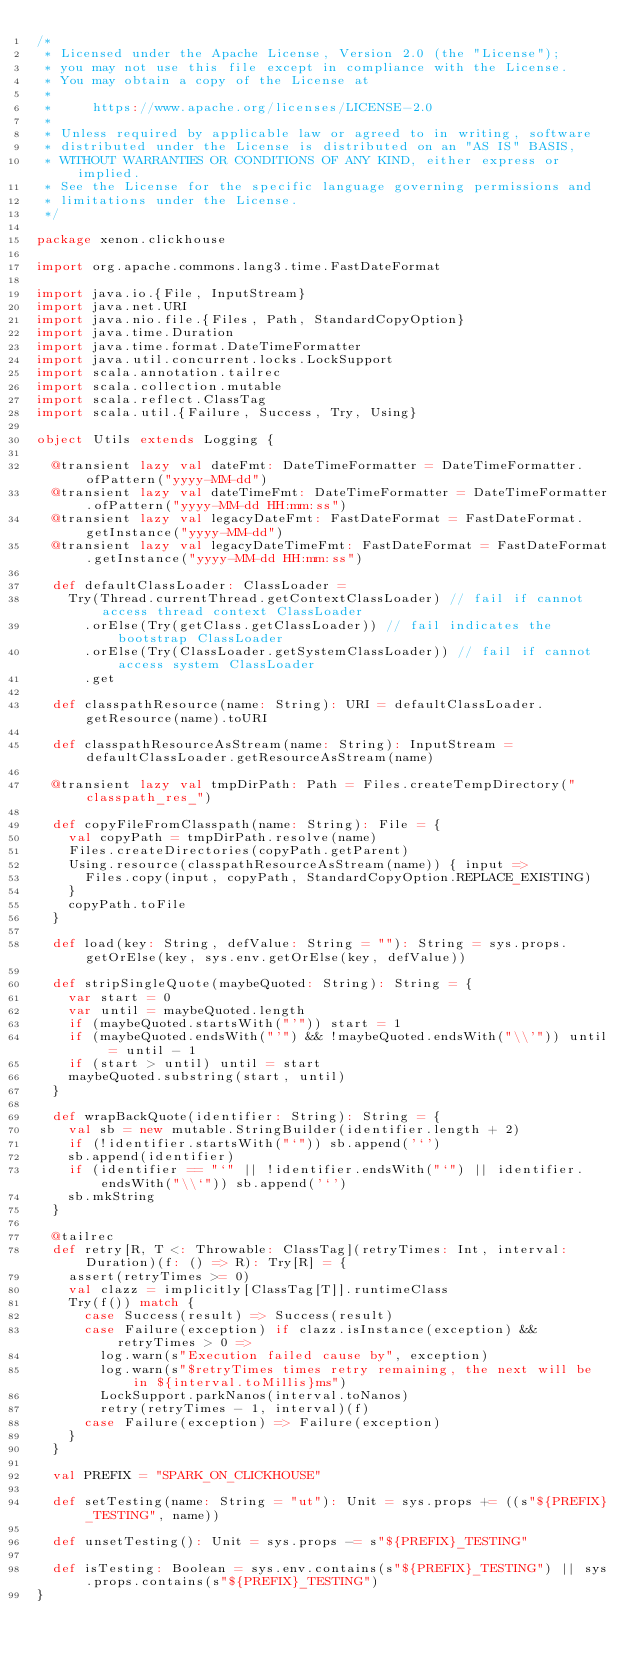<code> <loc_0><loc_0><loc_500><loc_500><_Scala_>/*
 * Licensed under the Apache License, Version 2.0 (the "License");
 * you may not use this file except in compliance with the License.
 * You may obtain a copy of the License at
 *
 *     https://www.apache.org/licenses/LICENSE-2.0
 *
 * Unless required by applicable law or agreed to in writing, software
 * distributed under the License is distributed on an "AS IS" BASIS,
 * WITHOUT WARRANTIES OR CONDITIONS OF ANY KIND, either express or implied.
 * See the License for the specific language governing permissions and
 * limitations under the License.
 */

package xenon.clickhouse

import org.apache.commons.lang3.time.FastDateFormat

import java.io.{File, InputStream}
import java.net.URI
import java.nio.file.{Files, Path, StandardCopyOption}
import java.time.Duration
import java.time.format.DateTimeFormatter
import java.util.concurrent.locks.LockSupport
import scala.annotation.tailrec
import scala.collection.mutable
import scala.reflect.ClassTag
import scala.util.{Failure, Success, Try, Using}

object Utils extends Logging {

  @transient lazy val dateFmt: DateTimeFormatter = DateTimeFormatter.ofPattern("yyyy-MM-dd")
  @transient lazy val dateTimeFmt: DateTimeFormatter = DateTimeFormatter.ofPattern("yyyy-MM-dd HH:mm:ss")
  @transient lazy val legacyDateFmt: FastDateFormat = FastDateFormat.getInstance("yyyy-MM-dd")
  @transient lazy val legacyDateTimeFmt: FastDateFormat = FastDateFormat.getInstance("yyyy-MM-dd HH:mm:ss")

  def defaultClassLoader: ClassLoader =
    Try(Thread.currentThread.getContextClassLoader) // fail if cannot access thread context ClassLoader
      .orElse(Try(getClass.getClassLoader)) // fail indicates the bootstrap ClassLoader
      .orElse(Try(ClassLoader.getSystemClassLoader)) // fail if cannot access system ClassLoader
      .get

  def classpathResource(name: String): URI = defaultClassLoader.getResource(name).toURI

  def classpathResourceAsStream(name: String): InputStream = defaultClassLoader.getResourceAsStream(name)

  @transient lazy val tmpDirPath: Path = Files.createTempDirectory("classpath_res_")

  def copyFileFromClasspath(name: String): File = {
    val copyPath = tmpDirPath.resolve(name)
    Files.createDirectories(copyPath.getParent)
    Using.resource(classpathResourceAsStream(name)) { input =>
      Files.copy(input, copyPath, StandardCopyOption.REPLACE_EXISTING)
    }
    copyPath.toFile
  }

  def load(key: String, defValue: String = ""): String = sys.props.getOrElse(key, sys.env.getOrElse(key, defValue))

  def stripSingleQuote(maybeQuoted: String): String = {
    var start = 0
    var until = maybeQuoted.length
    if (maybeQuoted.startsWith("'")) start = 1
    if (maybeQuoted.endsWith("'") && !maybeQuoted.endsWith("\\'")) until = until - 1
    if (start > until) until = start
    maybeQuoted.substring(start, until)
  }

  def wrapBackQuote(identifier: String): String = {
    val sb = new mutable.StringBuilder(identifier.length + 2)
    if (!identifier.startsWith("`")) sb.append('`')
    sb.append(identifier)
    if (identifier == "`" || !identifier.endsWith("`") || identifier.endsWith("\\`")) sb.append('`')
    sb.mkString
  }

  @tailrec
  def retry[R, T <: Throwable: ClassTag](retryTimes: Int, interval: Duration)(f: () => R): Try[R] = {
    assert(retryTimes >= 0)
    val clazz = implicitly[ClassTag[T]].runtimeClass
    Try(f()) match {
      case Success(result) => Success(result)
      case Failure(exception) if clazz.isInstance(exception) && retryTimes > 0 =>
        log.warn(s"Execution failed cause by", exception)
        log.warn(s"$retryTimes times retry remaining, the next will be in ${interval.toMillis}ms")
        LockSupport.parkNanos(interval.toNanos)
        retry(retryTimes - 1, interval)(f)
      case Failure(exception) => Failure(exception)
    }
  }

  val PREFIX = "SPARK_ON_CLICKHOUSE"

  def setTesting(name: String = "ut"): Unit = sys.props += ((s"${PREFIX}_TESTING", name))

  def unsetTesting(): Unit = sys.props -= s"${PREFIX}_TESTING"

  def isTesting: Boolean = sys.env.contains(s"${PREFIX}_TESTING") || sys.props.contains(s"${PREFIX}_TESTING")
}
</code> 